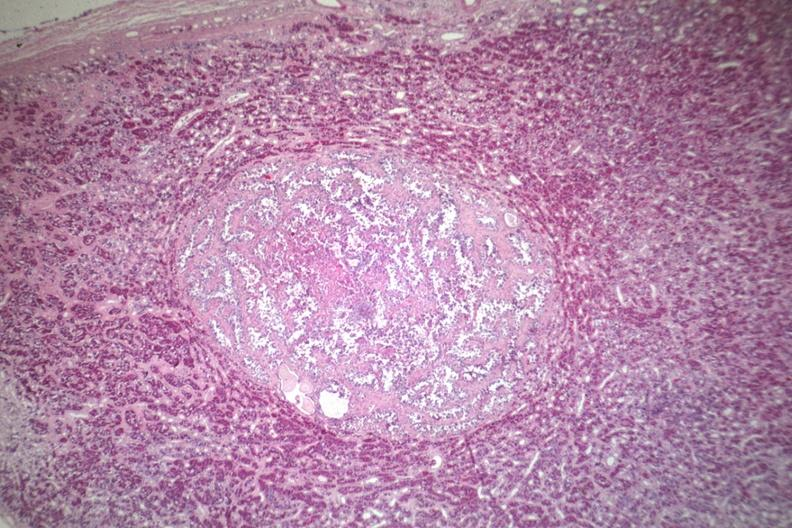what see for high mag?
Answer the question using a single word or phrase. Well circumscribed papillary lesion 